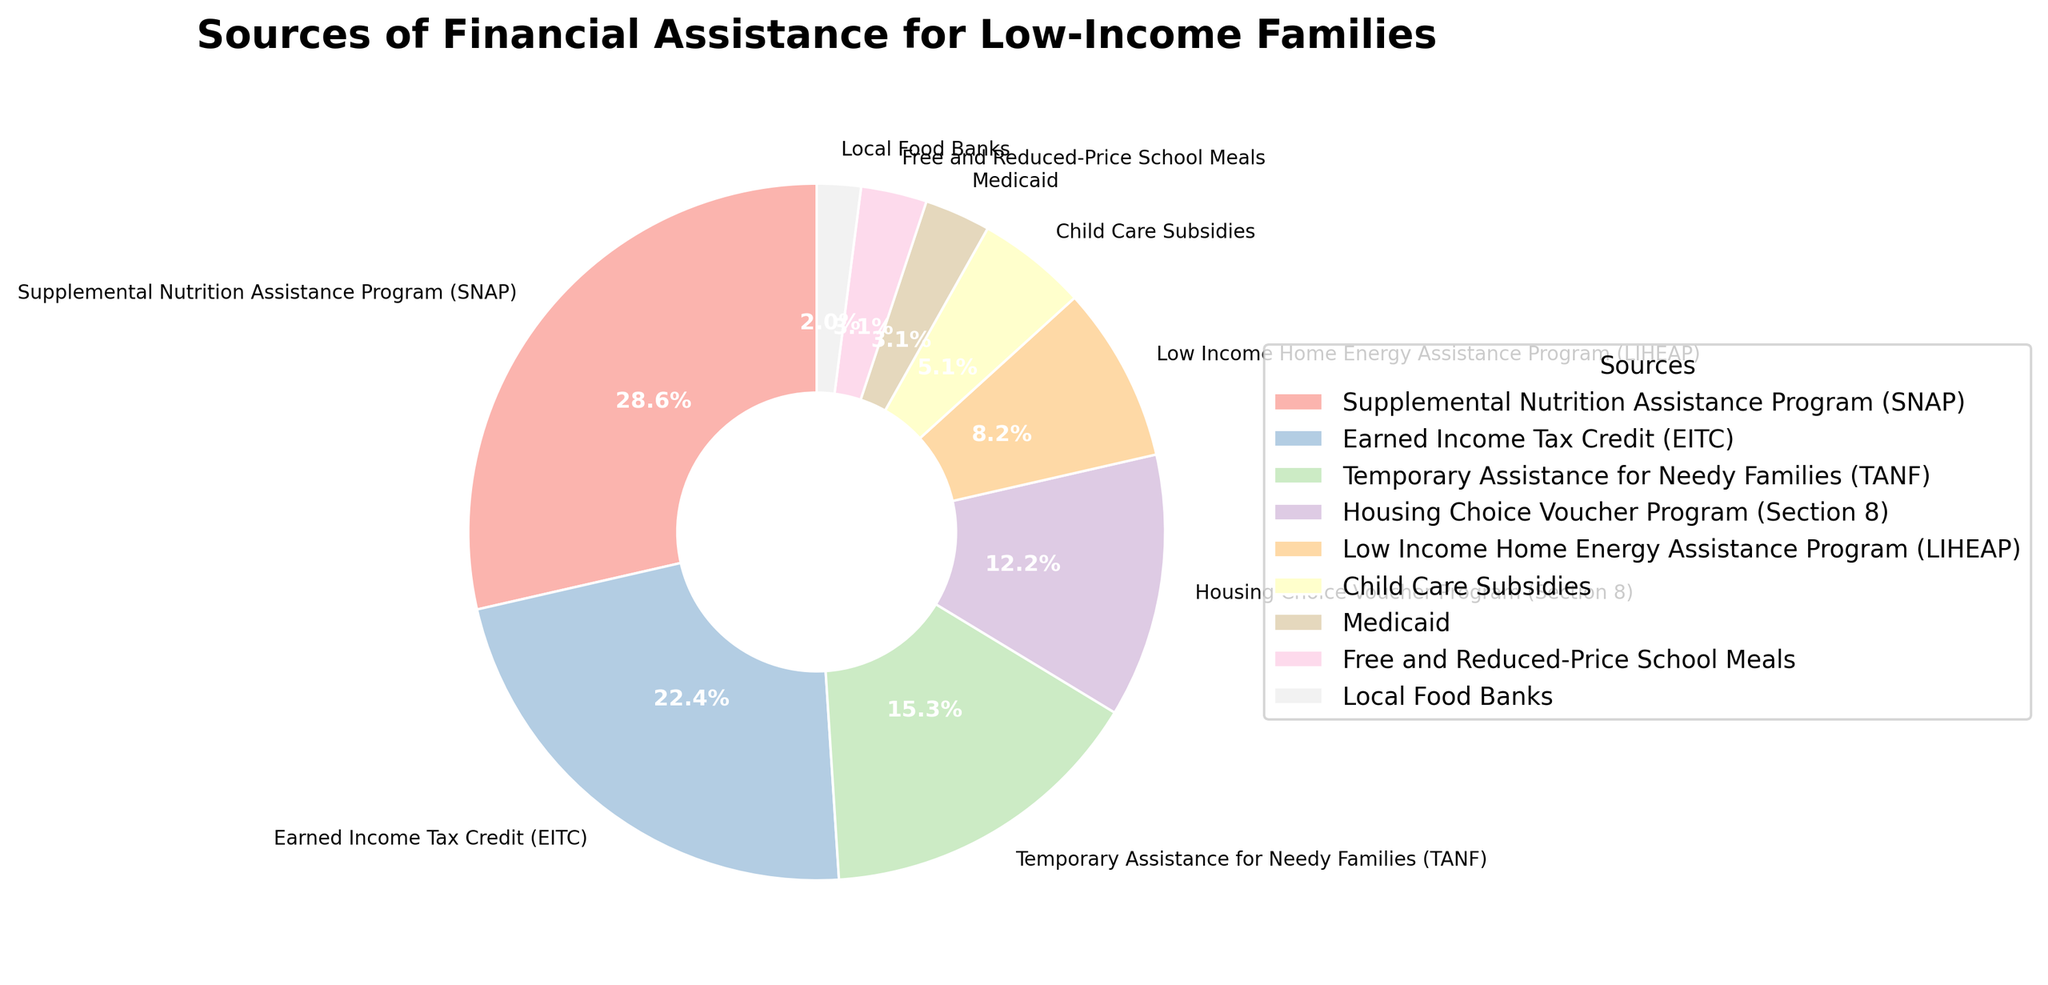What is the most accessed source of financial assistance for low-income families? The most accessed source is the one with the highest percentage in the pie chart. The highest percentage is 28%, which corresponds to the Supplemental Nutrition Assistance Program (SNAP).
Answer: Supplemental Nutrition Assistance Program (SNAP) Is the Earned Income Tax Credit (EITC) accessed more than Child Care Subsidies? Compare the percentages for EITC and Child Care Subsidies. EITC has 22% while Child Care Subsidies have 5%. Since 22% is greater than 5%, EITC is accessed more.
Answer: Yes What is the combined percentage of families accessing Temporary Assistance for Needy Families (TANF) and Housing Choice Voucher Program (Section 8)? Add the percentages of TANF and Section 8. TANF is 15% and Section 8 is 12%. Summing these gives 15% + 12% = 27%.
Answer: 27% Are there more families accessing Medicaid or Local Food Banks? Compare the percentages for Medicaid and Local Food Banks. Medicaid has 3%, while Local Food Banks have 2%. Since 3% is greater than 2%, more families access Medicaid.
Answer: Medicaid What two sources have an equal percentage of families accessing them? Look for two sources with the same percentage. Both Medicaid and Free and Reduced-Price School Meals have a percentage of 3%.
Answer: Medicaid and Free and Reduced-Price School Meals Which financial assistance source is accessed by the fewest families? The source with the smallest percentage in the pie chart is the least accessed. The smallest percentage is 2%, which corresponds to Local Food Banks.
Answer: Local Food Banks Which slice of the pie chart is visually larger, SNAP or EITC? The slice corresponding to SNAP (28%) is visually larger than the one corresponding to EITC (22%), as 28% is greater than 22%.
Answer: SNAP How much more popular is the Supplemental Nutrition Assistance Program (SNAP) compared to the Low Income Home Energy Assistance Program (LIHEAP)? Subtract the percentage of LIHEAP from the percentage of SNAP. SNAP is 28% and LIHEAP is 8%. 28% - 8% = 20%.
Answer: 20% What’s the total percentage of families accessing programs related to housing (Housing Choice Voucher Program) and energy assistance (Low Income Home Energy Assistance Program)? Add the percentages of Section 8 and LIHEAP. Section 8 is 12% and LIHEAP is 8%. 12% + 8% = 20%.
Answer: 20% Which programs combined make up nearly half of the pie chart? Identify the programs whose combined percentages approximate 50%. SNAP (28%) and EITC (22%). 28% + 22% = 50%.
Answer: SNAP and EITC 